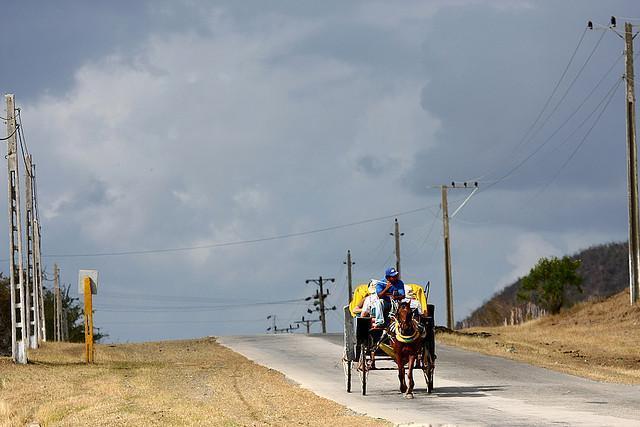How many yellow poles?
Give a very brief answer. 1. How many cats are there?
Give a very brief answer. 0. 